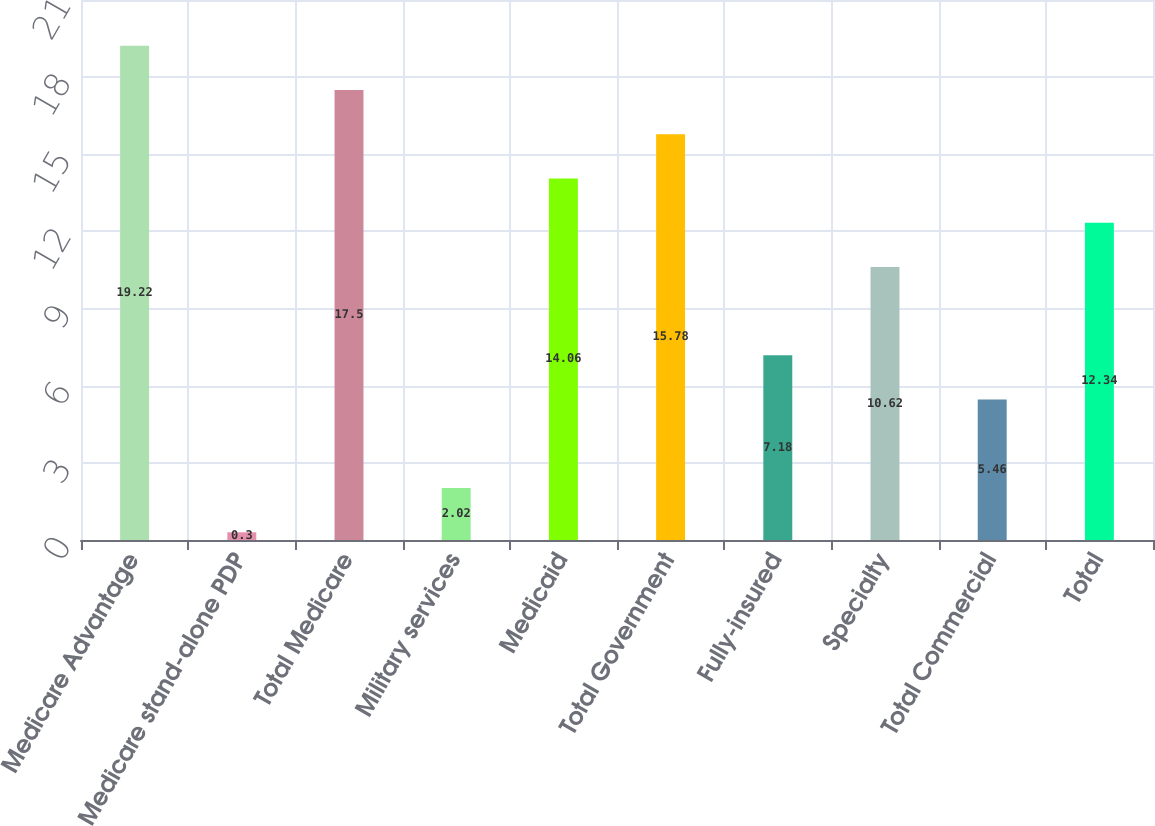Convert chart. <chart><loc_0><loc_0><loc_500><loc_500><bar_chart><fcel>Medicare Advantage<fcel>Medicare stand-alone PDP<fcel>Total Medicare<fcel>Military services<fcel>Medicaid<fcel>Total Government<fcel>Fully-insured<fcel>Specialty<fcel>Total Commercial<fcel>Total<nl><fcel>19.22<fcel>0.3<fcel>17.5<fcel>2.02<fcel>14.06<fcel>15.78<fcel>7.18<fcel>10.62<fcel>5.46<fcel>12.34<nl></chart> 